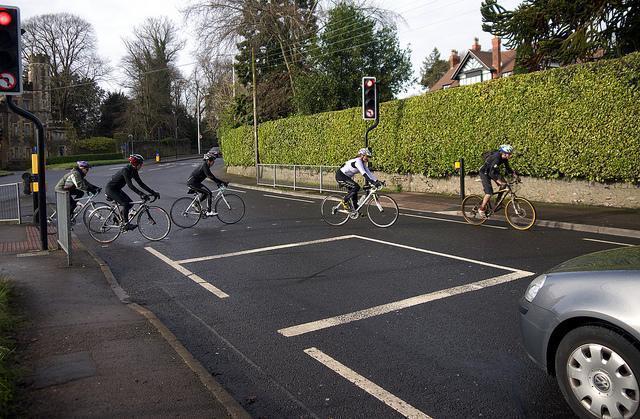If you're in a car coming from this way what is forbidden?
Select the accurate response from the four choices given to answer the question.
Options: Going forwards, turning right, waiting, turning left. Turning left. 